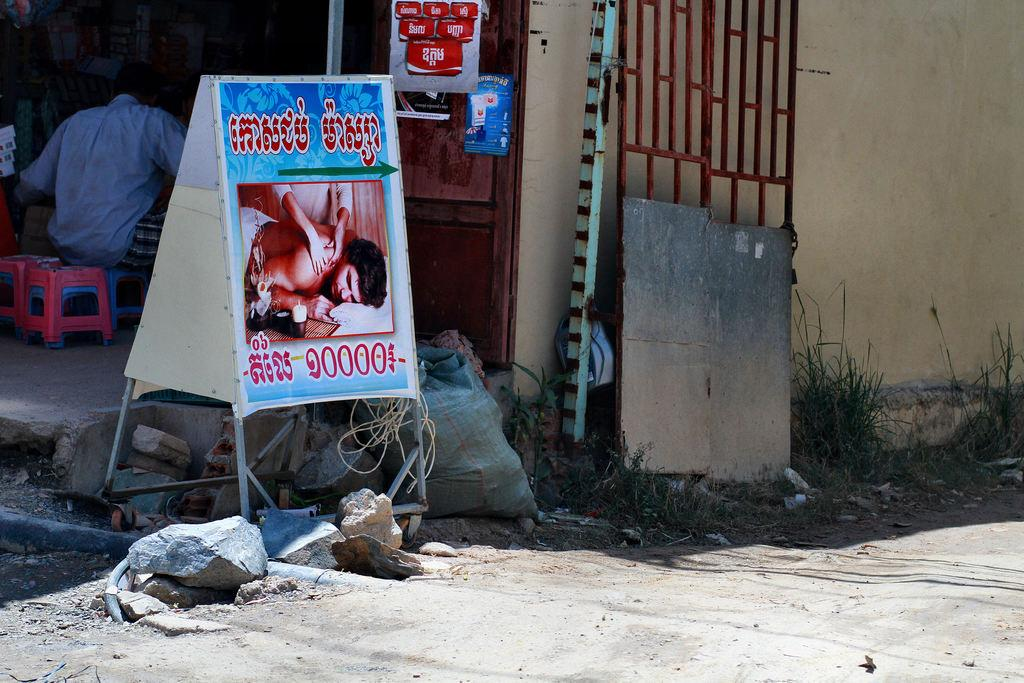What is the main object in the image? There is a board in the image. What can be seen on the ground in the image? There are stones and grass in the image. What architectural feature is present in the image? There is a gate in the image, and there is a wall behind the gate. What is the man in the image doing? The man is sitting on a stool behind the board. What else might be behind the board? There are other unspecified things behind the board. How many servants are present in the image? There is no mention of servants in the image, so it cannot be determined how many are present. Does the existence of the board in the image prove the existence of a parallel universe? The presence of the board in the image does not prove the existence of a parallel universe, as the board is a physical object in the image and not a metaphysical concept. What type of kettle can be seen boiling water behind the board? There is no kettle present in the image, so it cannot be determined if there is one boiling water behind the board. 